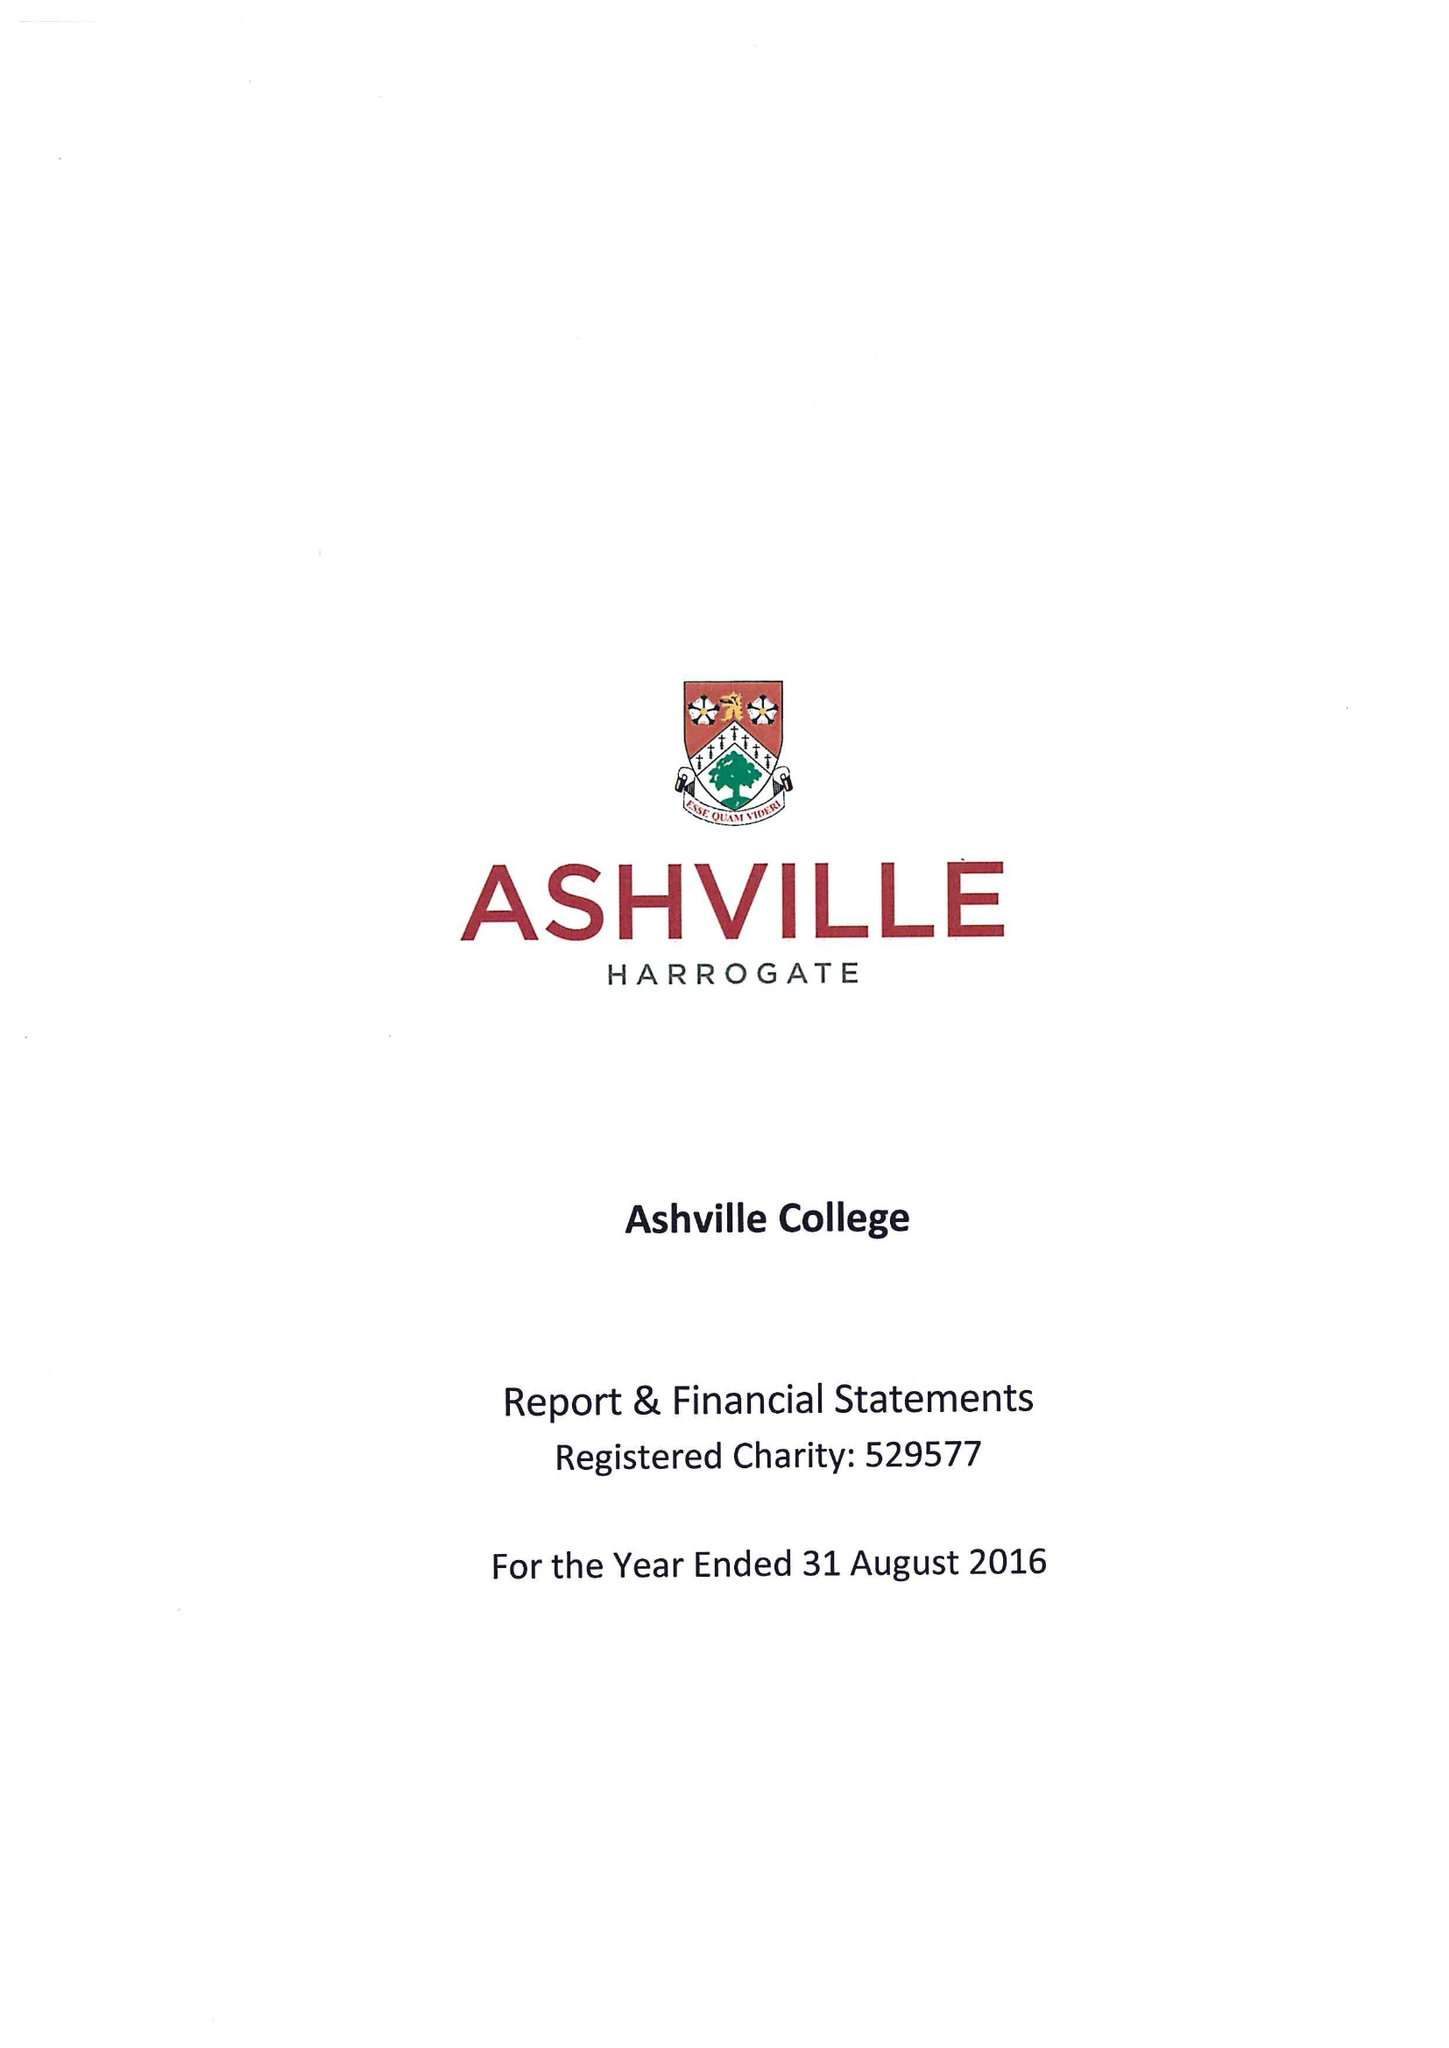What is the value for the income_annually_in_british_pounds?
Answer the question using a single word or phrase. 11689003.00 